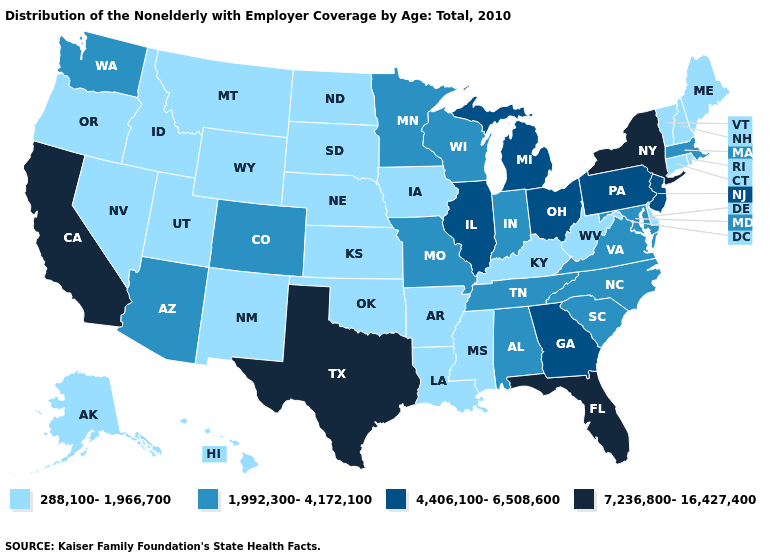Does Connecticut have a lower value than Florida?
Concise answer only. Yes. What is the value of Idaho?
Be succinct. 288,100-1,966,700. Among the states that border Idaho , which have the highest value?
Concise answer only. Washington. Does Pennsylvania have the highest value in the Northeast?
Short answer required. No. Is the legend a continuous bar?
Give a very brief answer. No. What is the value of Nebraska?
Short answer required. 288,100-1,966,700. What is the value of Nevada?
Concise answer only. 288,100-1,966,700. What is the highest value in states that border New Mexico?
Quick response, please. 7,236,800-16,427,400. Name the states that have a value in the range 7,236,800-16,427,400?
Write a very short answer. California, Florida, New York, Texas. Name the states that have a value in the range 7,236,800-16,427,400?
Keep it brief. California, Florida, New York, Texas. Does New York have the highest value in the Northeast?
Short answer required. Yes. Among the states that border South Carolina , does North Carolina have the highest value?
Be succinct. No. Does Oregon have a lower value than Michigan?
Give a very brief answer. Yes. What is the value of Mississippi?
Answer briefly. 288,100-1,966,700. What is the value of Arizona?
Concise answer only. 1,992,300-4,172,100. 